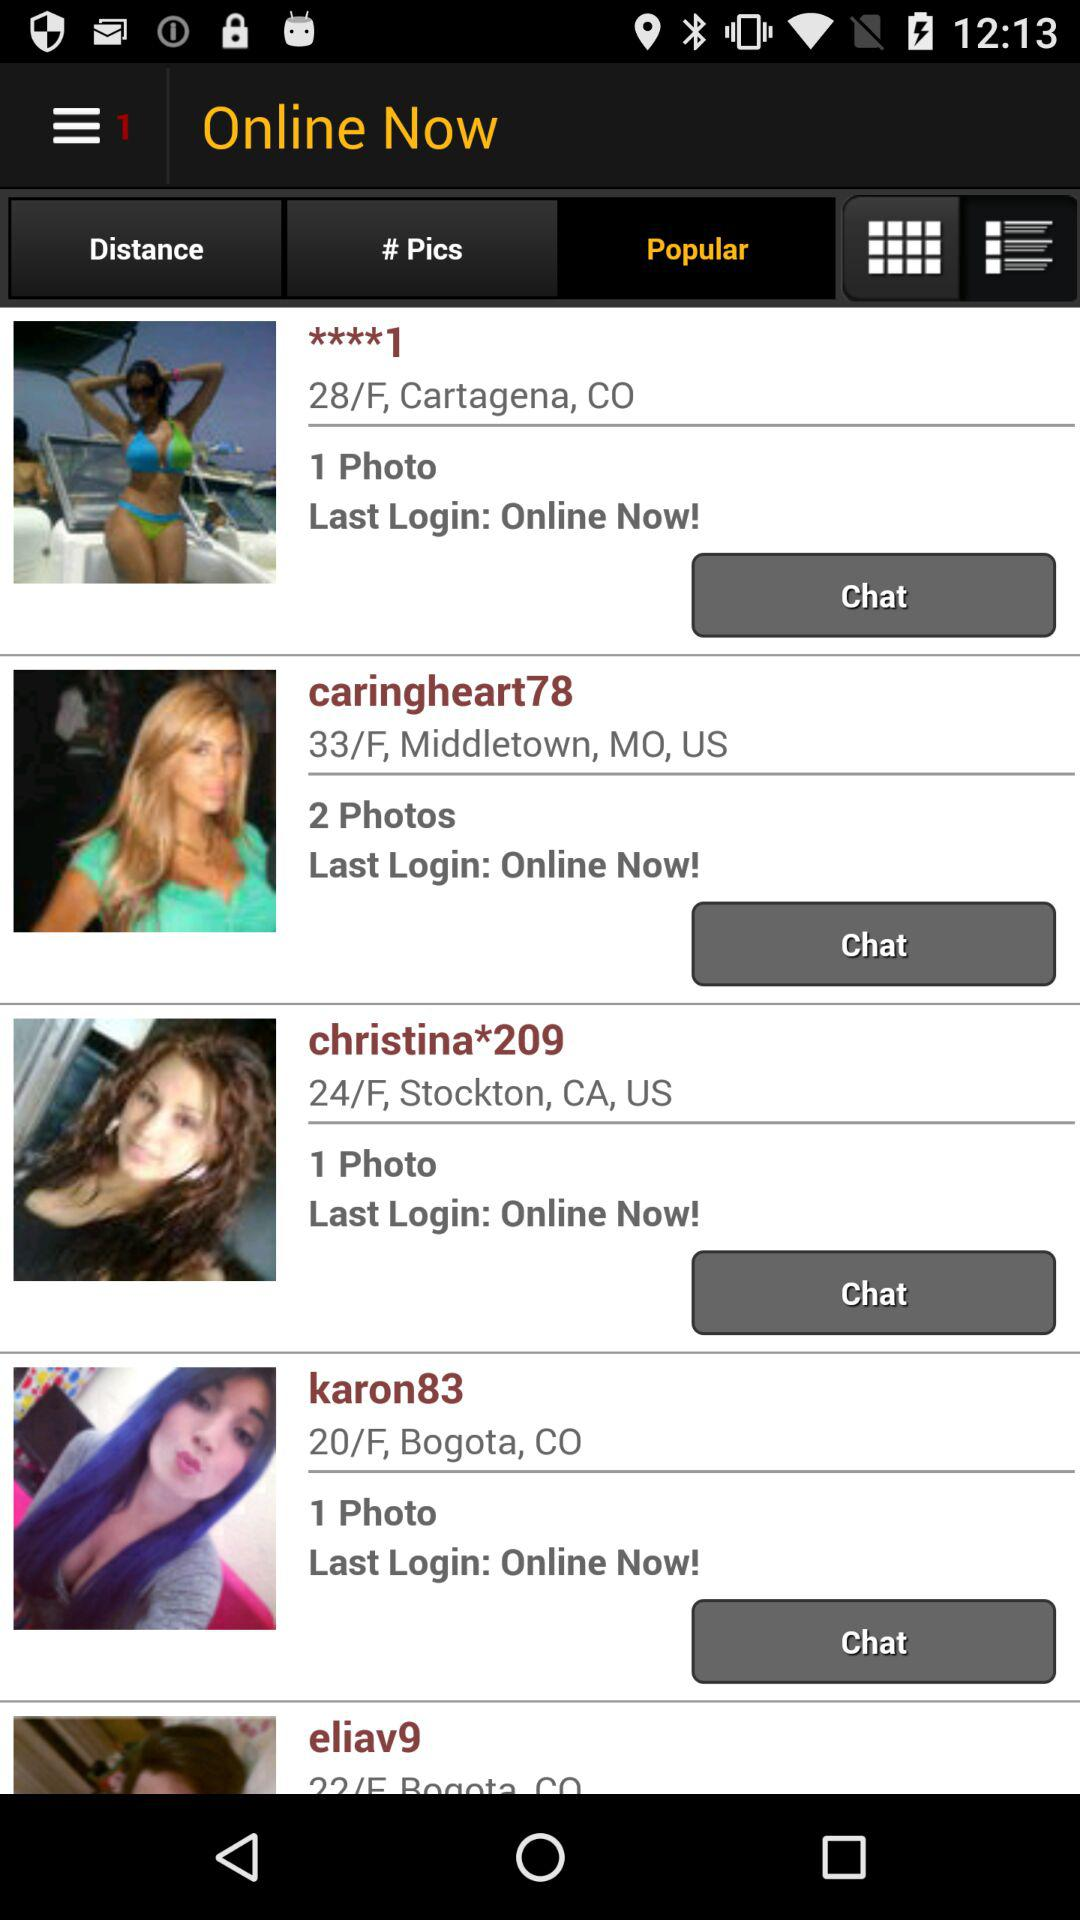How many photos are there in the "caringheart78" profile? There are 2 photos in the "caringheart78" profile. 